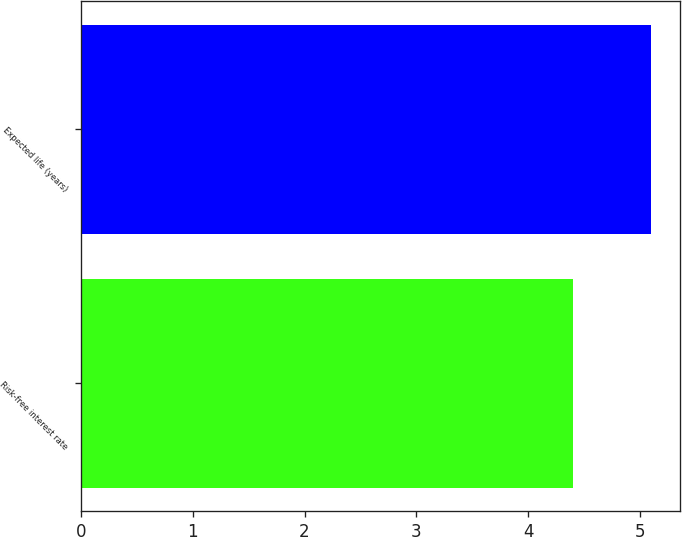Convert chart to OTSL. <chart><loc_0><loc_0><loc_500><loc_500><bar_chart><fcel>Risk-free interest rate<fcel>Expected life (years)<nl><fcel>4.4<fcel>5.1<nl></chart> 